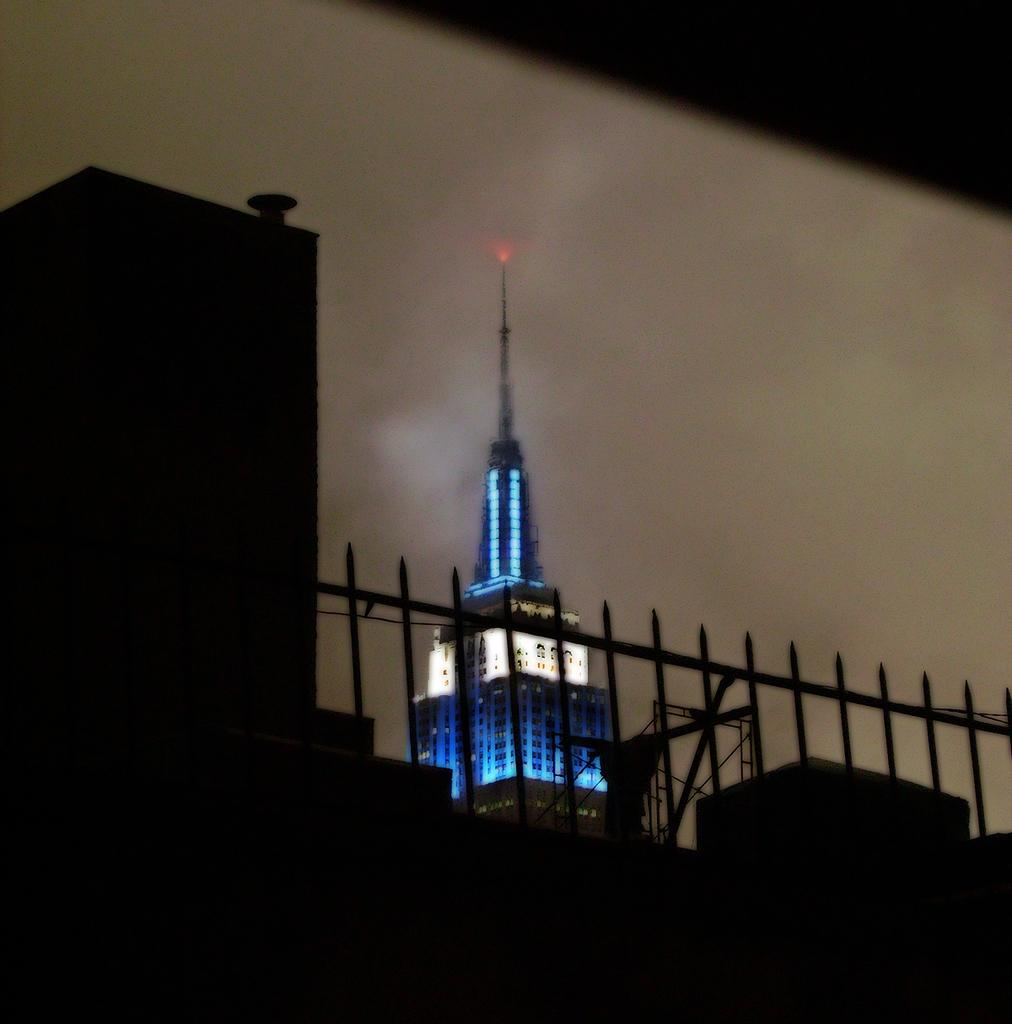What type of structures can be seen in the image? There are buildings in the image. Can you describe a specific building in the image? There is a building with lights in the image. What type of barrier is present in the image? There is an iron fence in the image. What can be seen in the background of the image? The sky is visible in the background of the image. What type of voice can be heard coming from the nation in the image? There is no nation or voice present in the image; it only features buildings and an iron fence. Is there any eggnog visible in the image? There is no eggnog present in the image. 